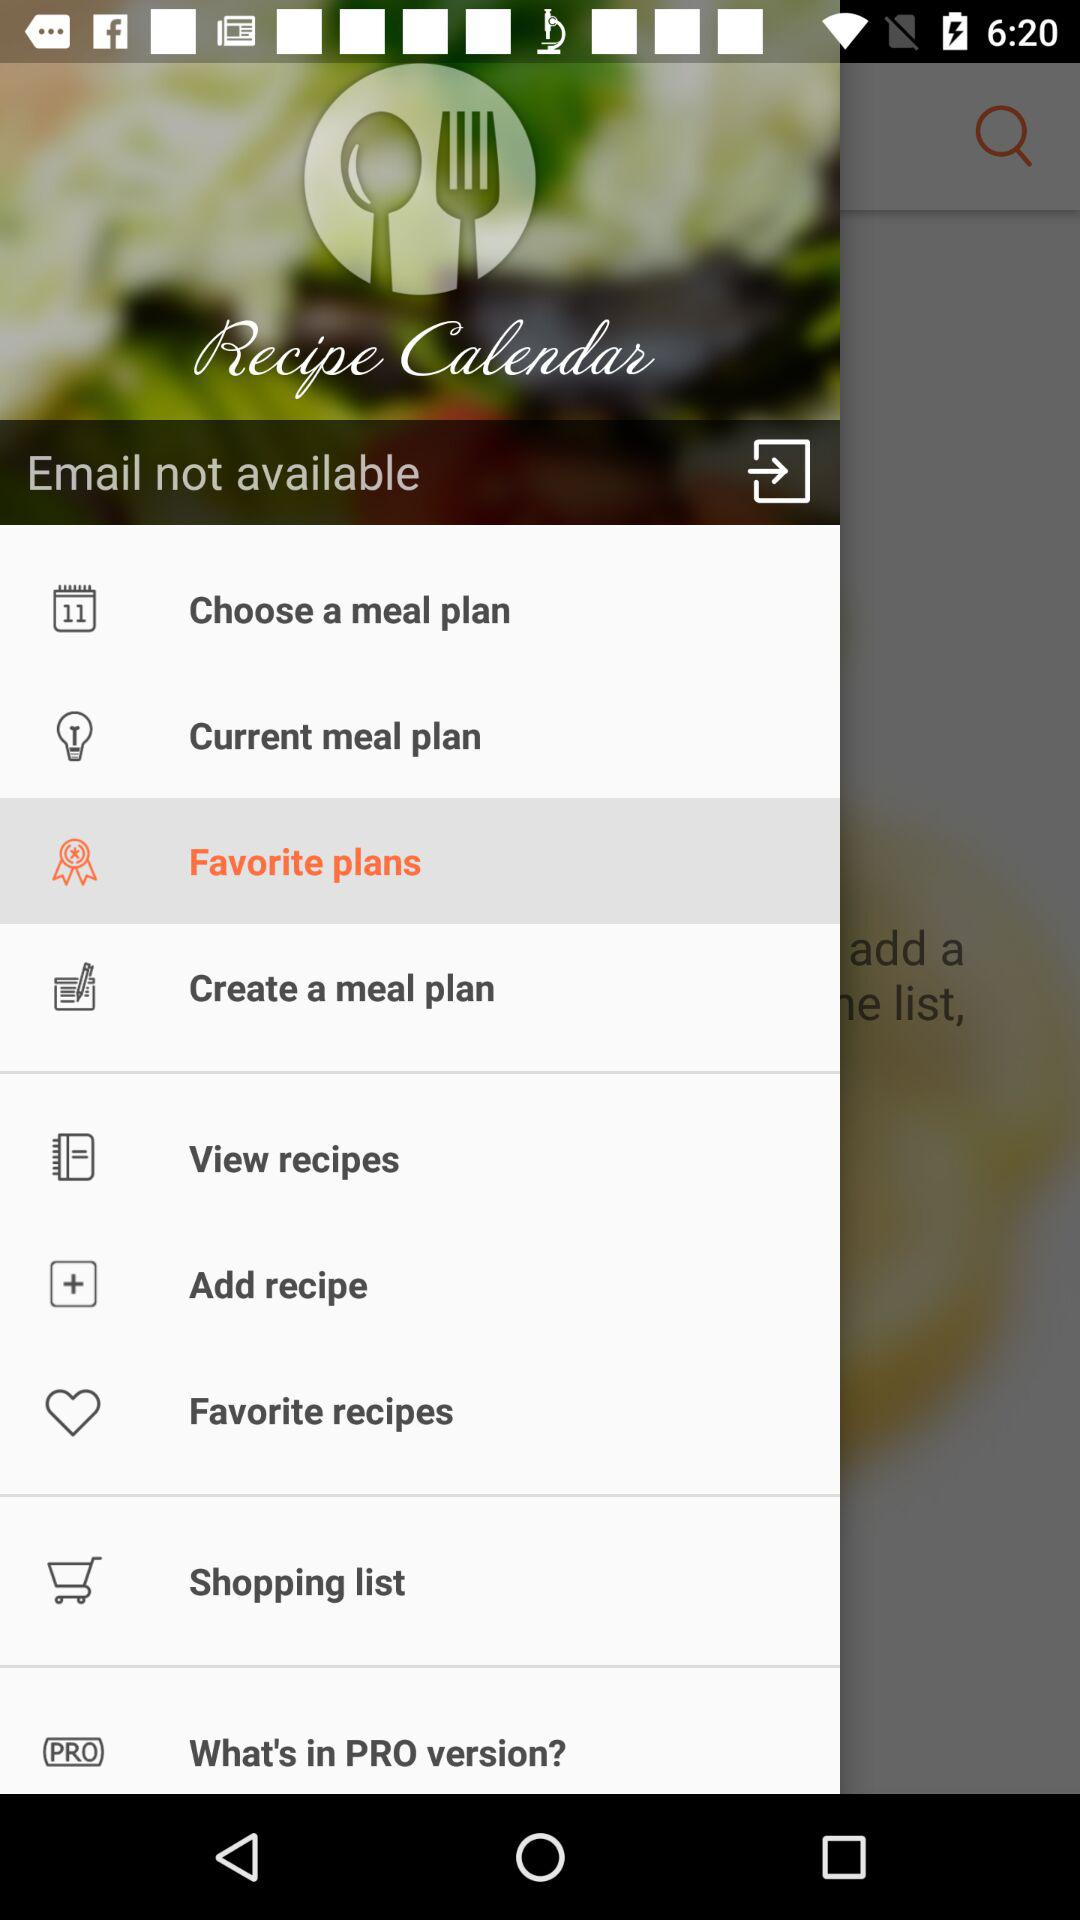What is the application name? The application name is "Recipe Calendar". 